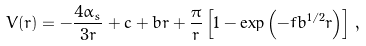<formula> <loc_0><loc_0><loc_500><loc_500>V ( r ) = - { \frac { 4 \alpha _ { s } } { 3 r } } + c + b r + { \frac { \pi } { r } } \left [ 1 - \exp \left ( - f b ^ { 1 / 2 } r \right ) \right ] \, ,</formula> 